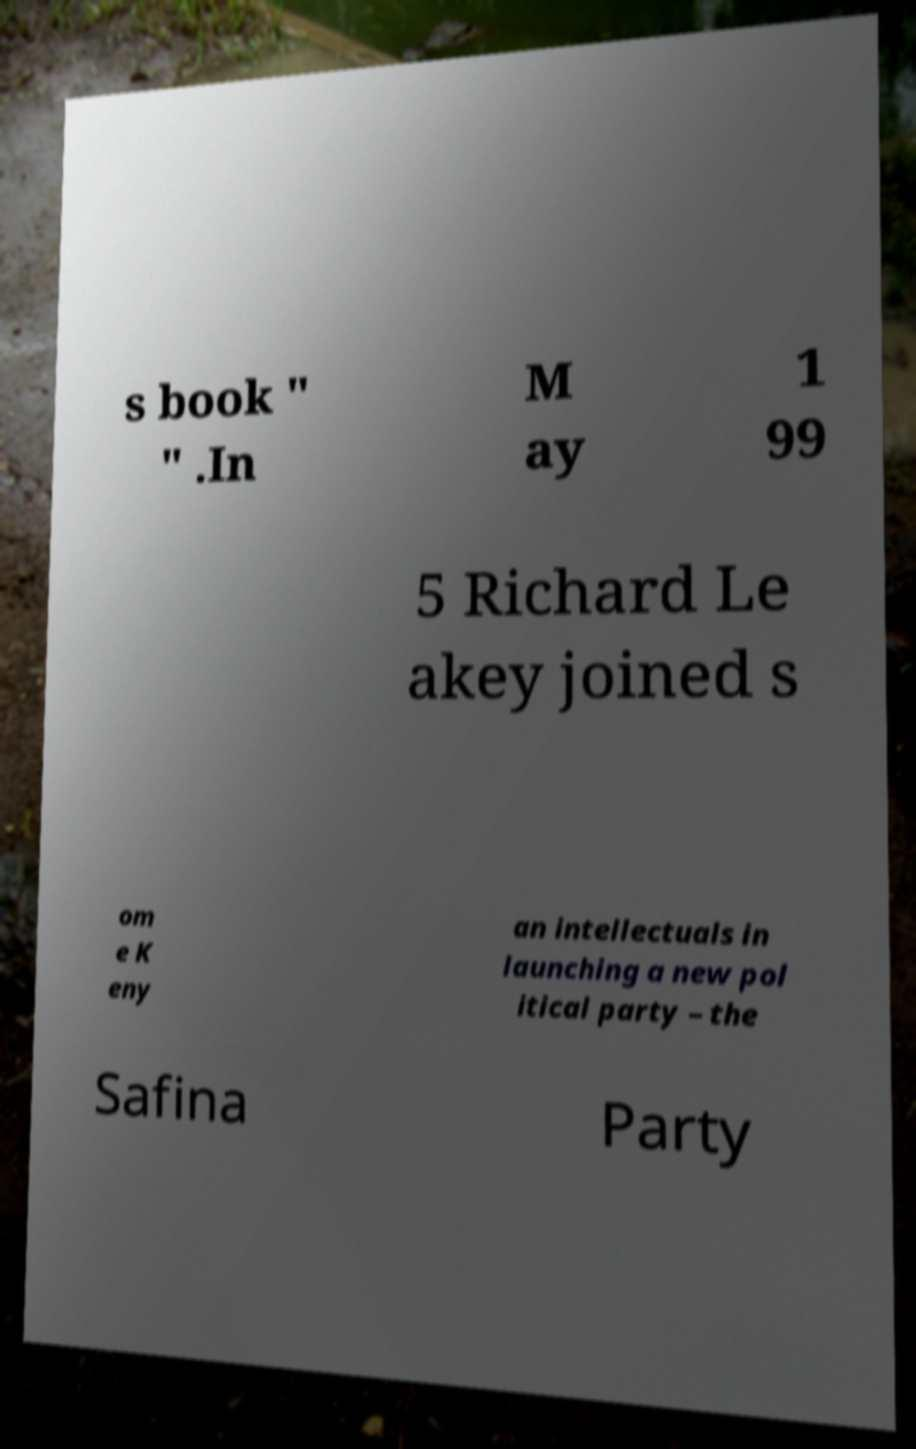Can you read and provide the text displayed in the image?This photo seems to have some interesting text. Can you extract and type it out for me? s book " " .In M ay 1 99 5 Richard Le akey joined s om e K eny an intellectuals in launching a new pol itical party – the Safina Party 